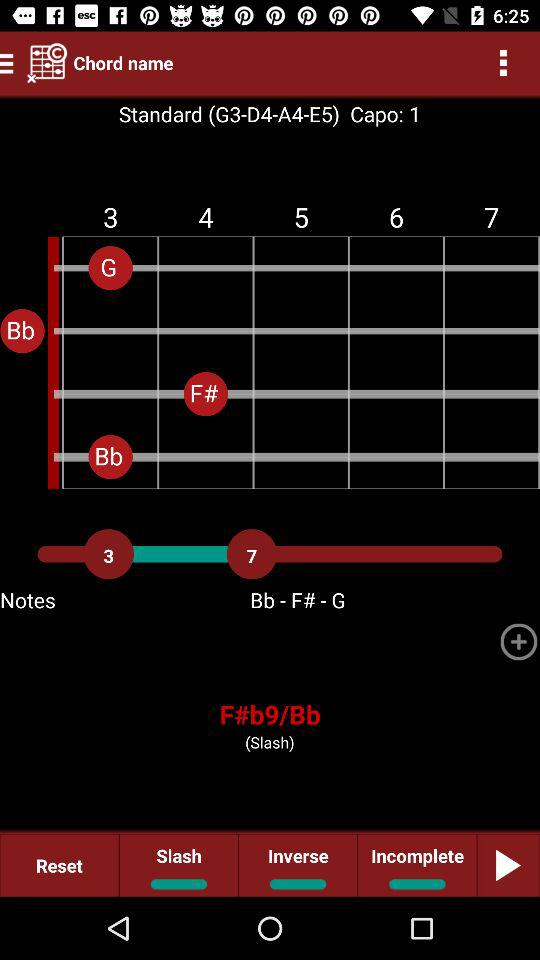Which option is selected in the slash?
When the provided information is insufficient, respond with <no answer>. <no answer> 